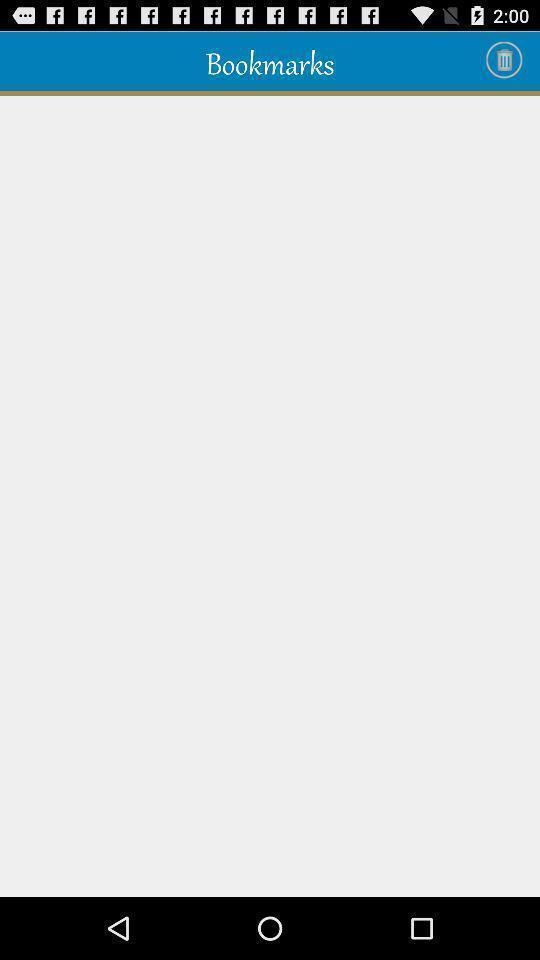Explain the elements present in this screenshot. Screen displaying a blank page. 